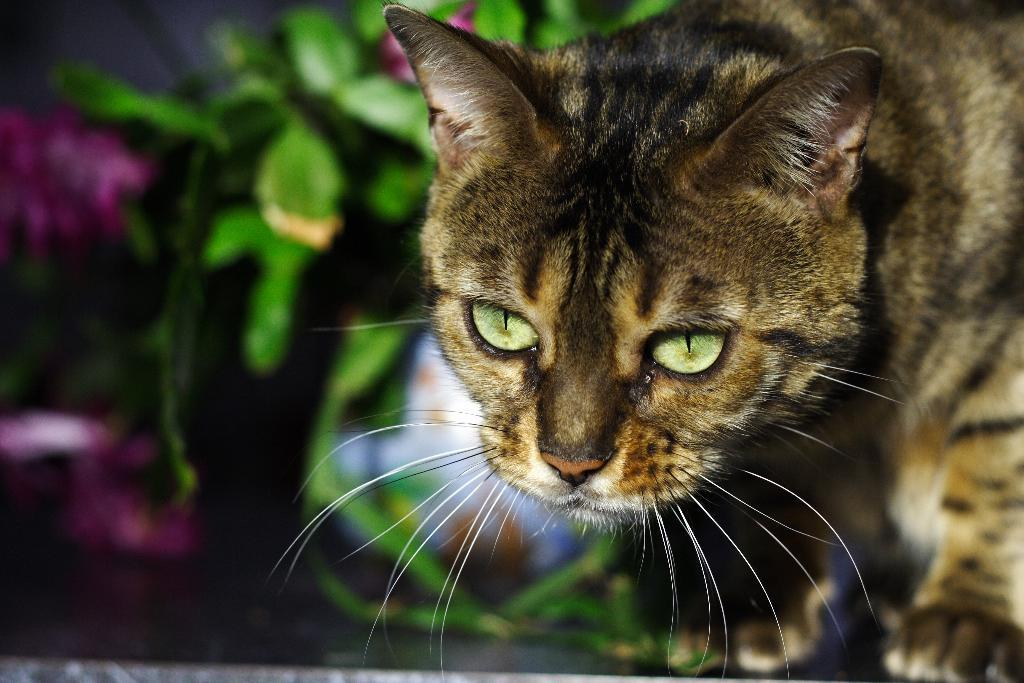What type of animal is in the image? There is a cat in the image. What type of vegetation is present in the image? There are green leaves in the image. How many brothers does the cat have in the image? There is no information about the cat's brothers in the image, as it only shows the cat and green leaves. 